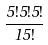<formula> <loc_0><loc_0><loc_500><loc_500>\frac { 5 ! 5 ! 5 ! } { 1 5 ! }</formula> 